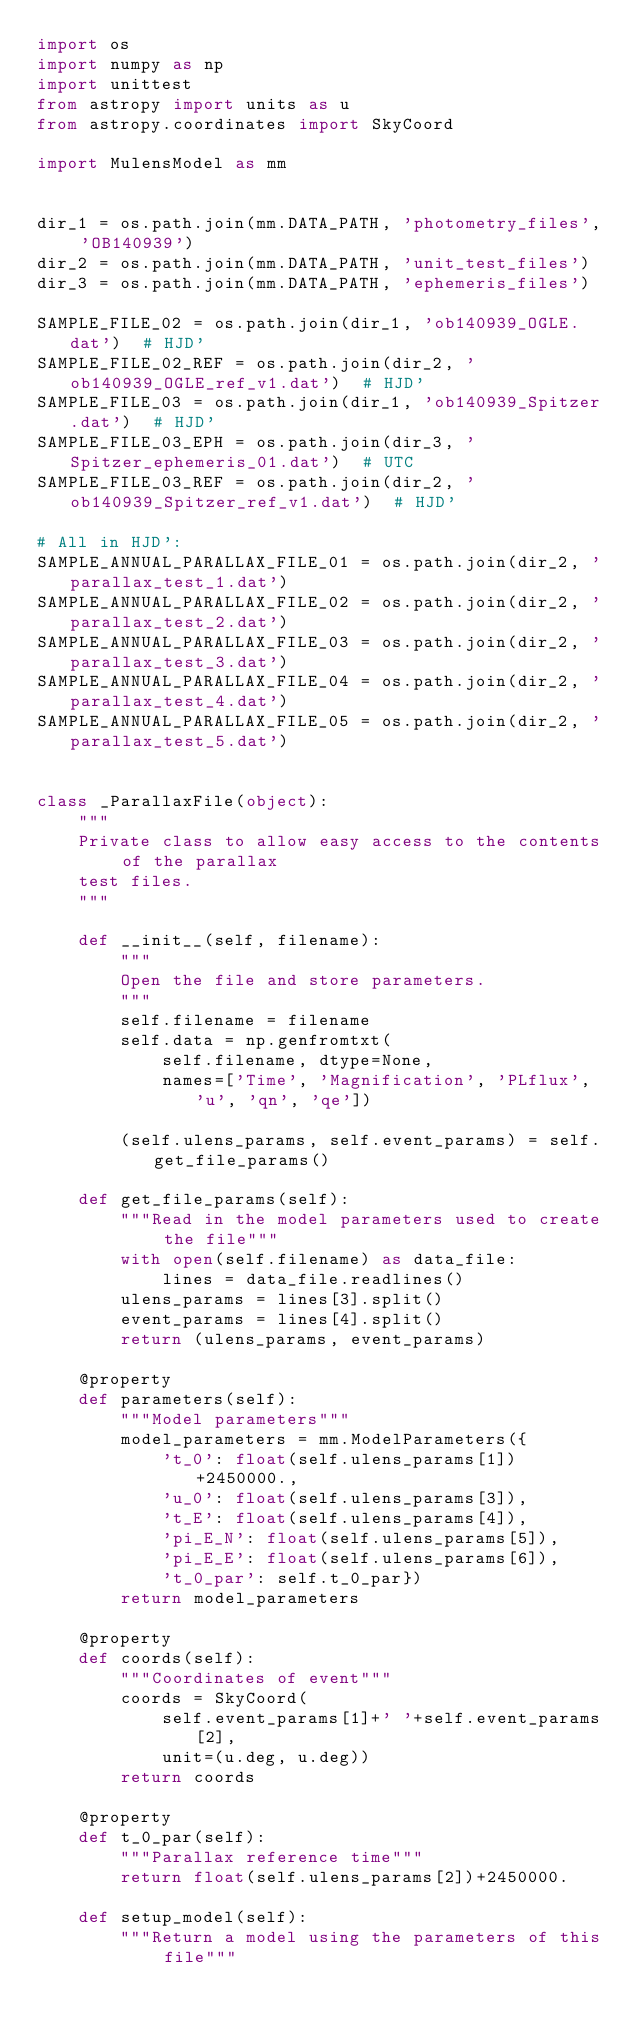<code> <loc_0><loc_0><loc_500><loc_500><_Python_>import os
import numpy as np
import unittest
from astropy import units as u
from astropy.coordinates import SkyCoord

import MulensModel as mm


dir_1 = os.path.join(mm.DATA_PATH, 'photometry_files', 'OB140939')
dir_2 = os.path.join(mm.DATA_PATH, 'unit_test_files')
dir_3 = os.path.join(mm.DATA_PATH, 'ephemeris_files')

SAMPLE_FILE_02 = os.path.join(dir_1, 'ob140939_OGLE.dat')  # HJD'
SAMPLE_FILE_02_REF = os.path.join(dir_2, 'ob140939_OGLE_ref_v1.dat')  # HJD'
SAMPLE_FILE_03 = os.path.join(dir_1, 'ob140939_Spitzer.dat')  # HJD'
SAMPLE_FILE_03_EPH = os.path.join(dir_3, 'Spitzer_ephemeris_01.dat')  # UTC
SAMPLE_FILE_03_REF = os.path.join(dir_2, 'ob140939_Spitzer_ref_v1.dat')  # HJD'

# All in HJD':
SAMPLE_ANNUAL_PARALLAX_FILE_01 = os.path.join(dir_2, 'parallax_test_1.dat')
SAMPLE_ANNUAL_PARALLAX_FILE_02 = os.path.join(dir_2, 'parallax_test_2.dat')
SAMPLE_ANNUAL_PARALLAX_FILE_03 = os.path.join(dir_2, 'parallax_test_3.dat')
SAMPLE_ANNUAL_PARALLAX_FILE_04 = os.path.join(dir_2, 'parallax_test_4.dat')
SAMPLE_ANNUAL_PARALLAX_FILE_05 = os.path.join(dir_2, 'parallax_test_5.dat')


class _ParallaxFile(object):
    """
    Private class to allow easy access to the contents of the parallax
    test files.
    """

    def __init__(self, filename):
        """
        Open the file and store parameters.
        """
        self.filename = filename
        self.data = np.genfromtxt(
            self.filename, dtype=None,
            names=['Time', 'Magnification', 'PLflux', 'u', 'qn', 'qe'])

        (self.ulens_params, self.event_params) = self.get_file_params()

    def get_file_params(self):
        """Read in the model parameters used to create the file"""
        with open(self.filename) as data_file:
            lines = data_file.readlines()
        ulens_params = lines[3].split()
        event_params = lines[4].split()
        return (ulens_params, event_params)

    @property
    def parameters(self):
        """Model parameters"""
        model_parameters = mm.ModelParameters({
            't_0': float(self.ulens_params[1])+2450000.,
            'u_0': float(self.ulens_params[3]),
            't_E': float(self.ulens_params[4]),
            'pi_E_N': float(self.ulens_params[5]),
            'pi_E_E': float(self.ulens_params[6]),
            't_0_par': self.t_0_par})
        return model_parameters

    @property
    def coords(self):
        """Coordinates of event"""
        coords = SkyCoord(
            self.event_params[1]+' '+self.event_params[2],
            unit=(u.deg, u.deg))
        return coords

    @property
    def t_0_par(self):
        """Parallax reference time"""
        return float(self.ulens_params[2])+2450000.

    def setup_model(self):
        """Return a model using the parameters of this file"""</code> 